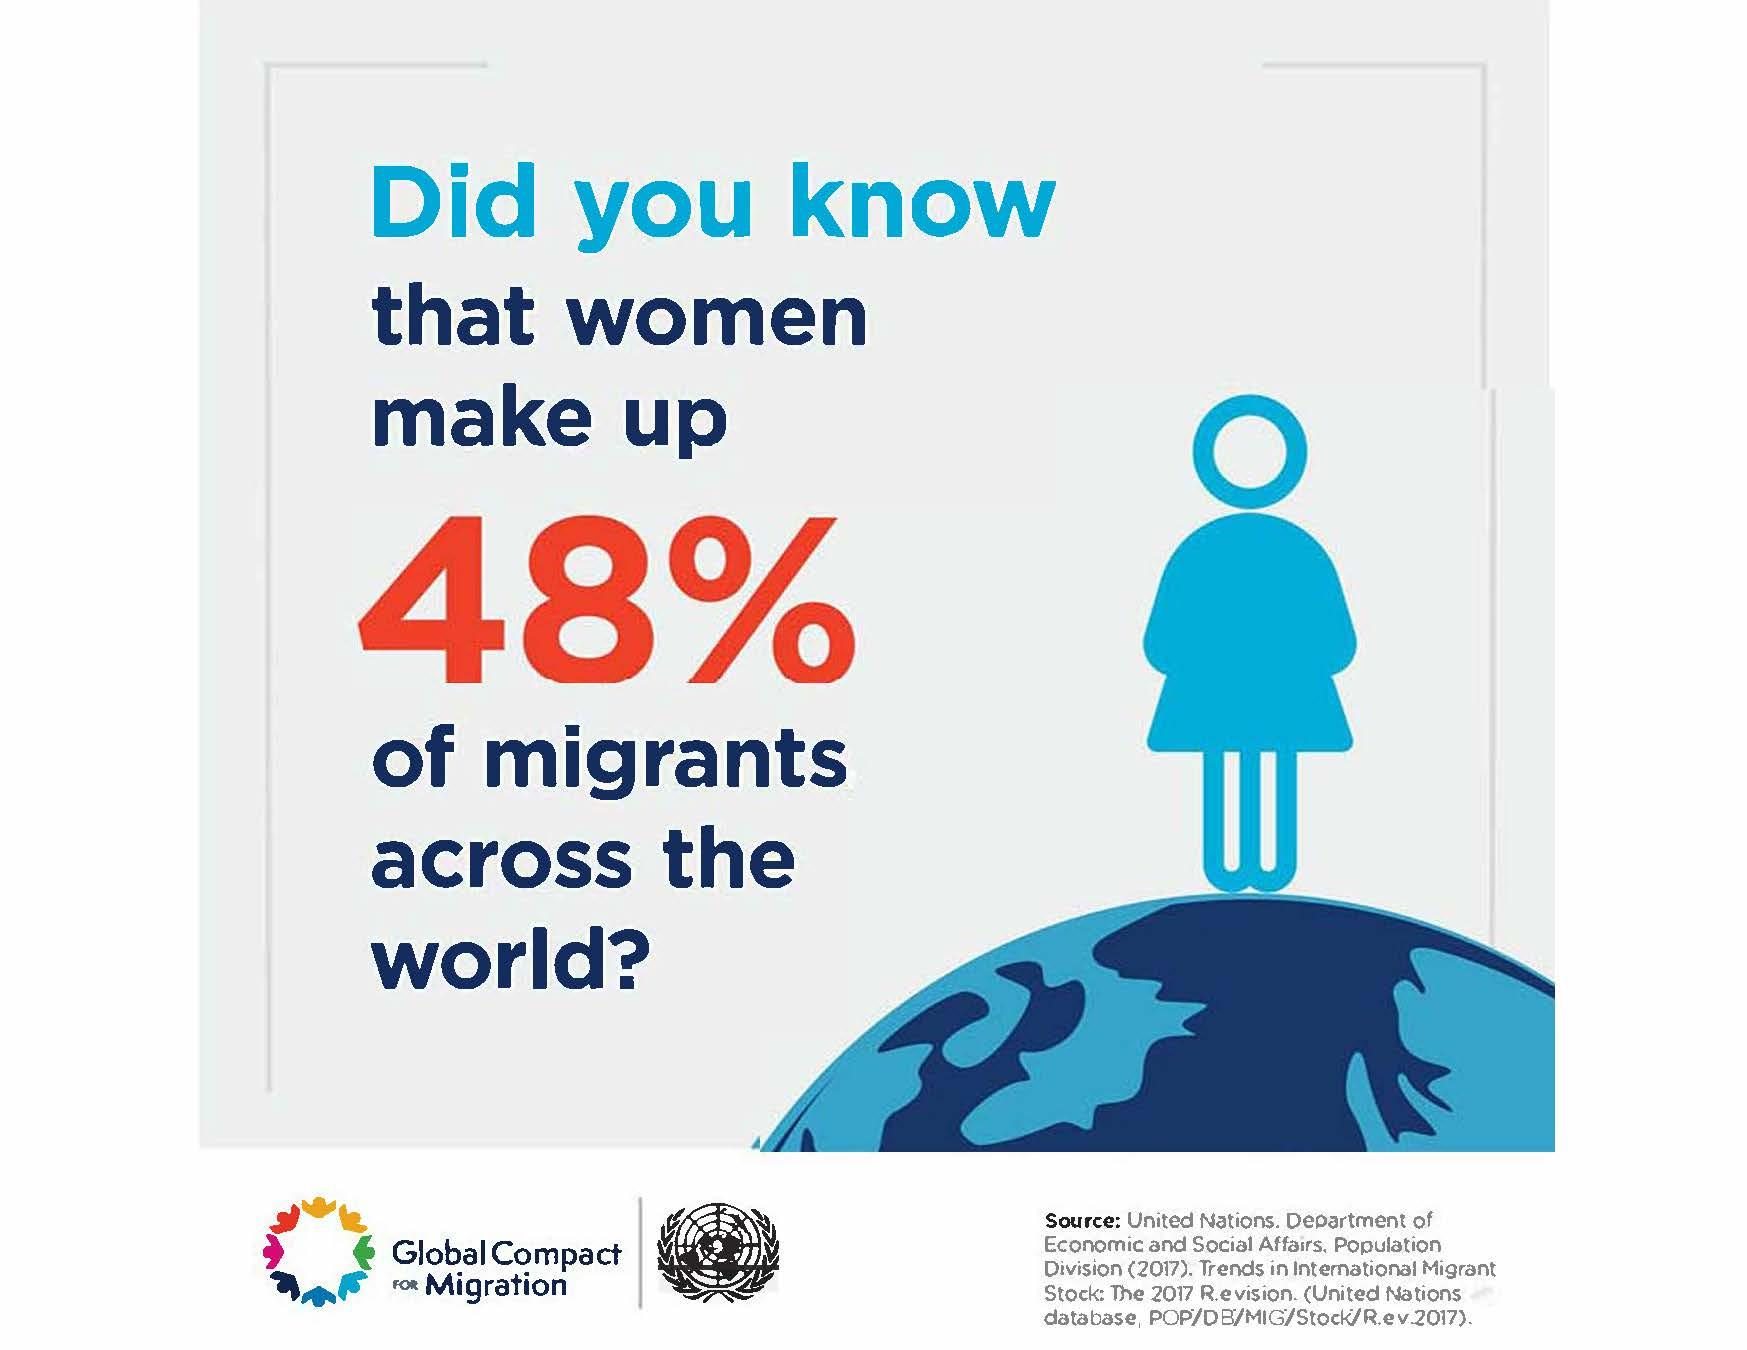Specify some key components in this picture. According to recent estimates, approximately 52% of migrants worldwide are men. 